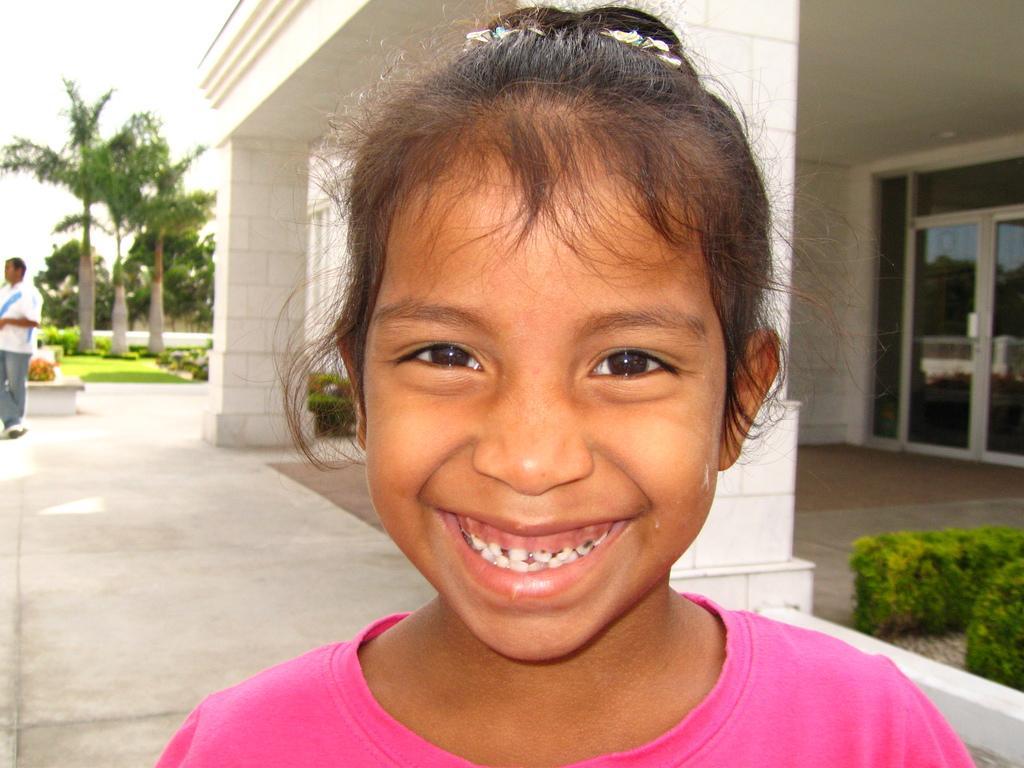Could you give a brief overview of what you see in this image? In this picture we can see the small girl wearing a pink color t-shirt, standing in the front smiling and giving a pose into the camera. Behind there is a white color pillar and a glass door. In the background there is a coconut trees in the garden area. 